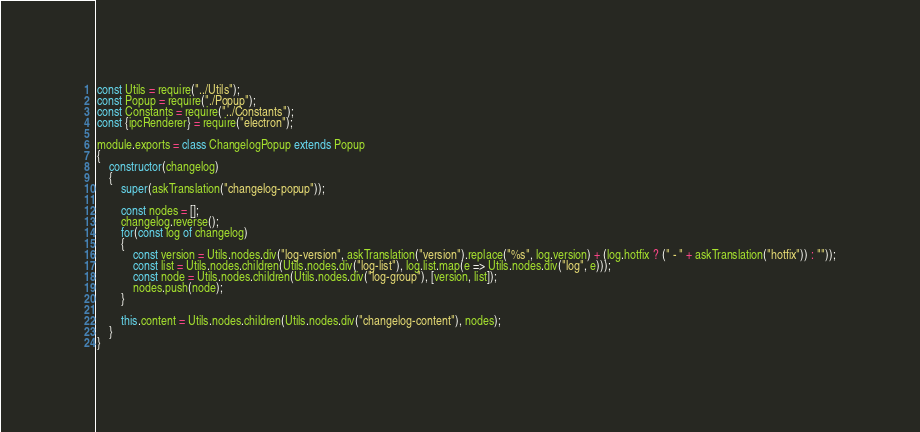Convert code to text. <code><loc_0><loc_0><loc_500><loc_500><_JavaScript_>const Utils = require("../Utils");
const Popup = require("./Popup");
const Constants = require("../Constants");
const {ipcRenderer} = require("electron");

module.exports = class ChangelogPopup extends Popup
{
	constructor(changelog)
	{
		super(askTranslation("changelog-popup"));
	
		const nodes = [];
		changelog.reverse();
		for(const log of changelog)
		{
			const version = Utils.nodes.div("log-version", askTranslation("version").replace("%s", log.version) + (log.hotfix ? (" - " + askTranslation("hotfix")) : ""));
			const list = Utils.nodes.children(Utils.nodes.div("log-list"), log.list.map(e => Utils.nodes.div("log", e)));
			const node = Utils.nodes.children(Utils.nodes.div("log-group"), [version, list]);
			nodes.push(node);
		}

		this.content = Utils.nodes.children(Utils.nodes.div("changelog-content"), nodes);
	}
}
</code> 